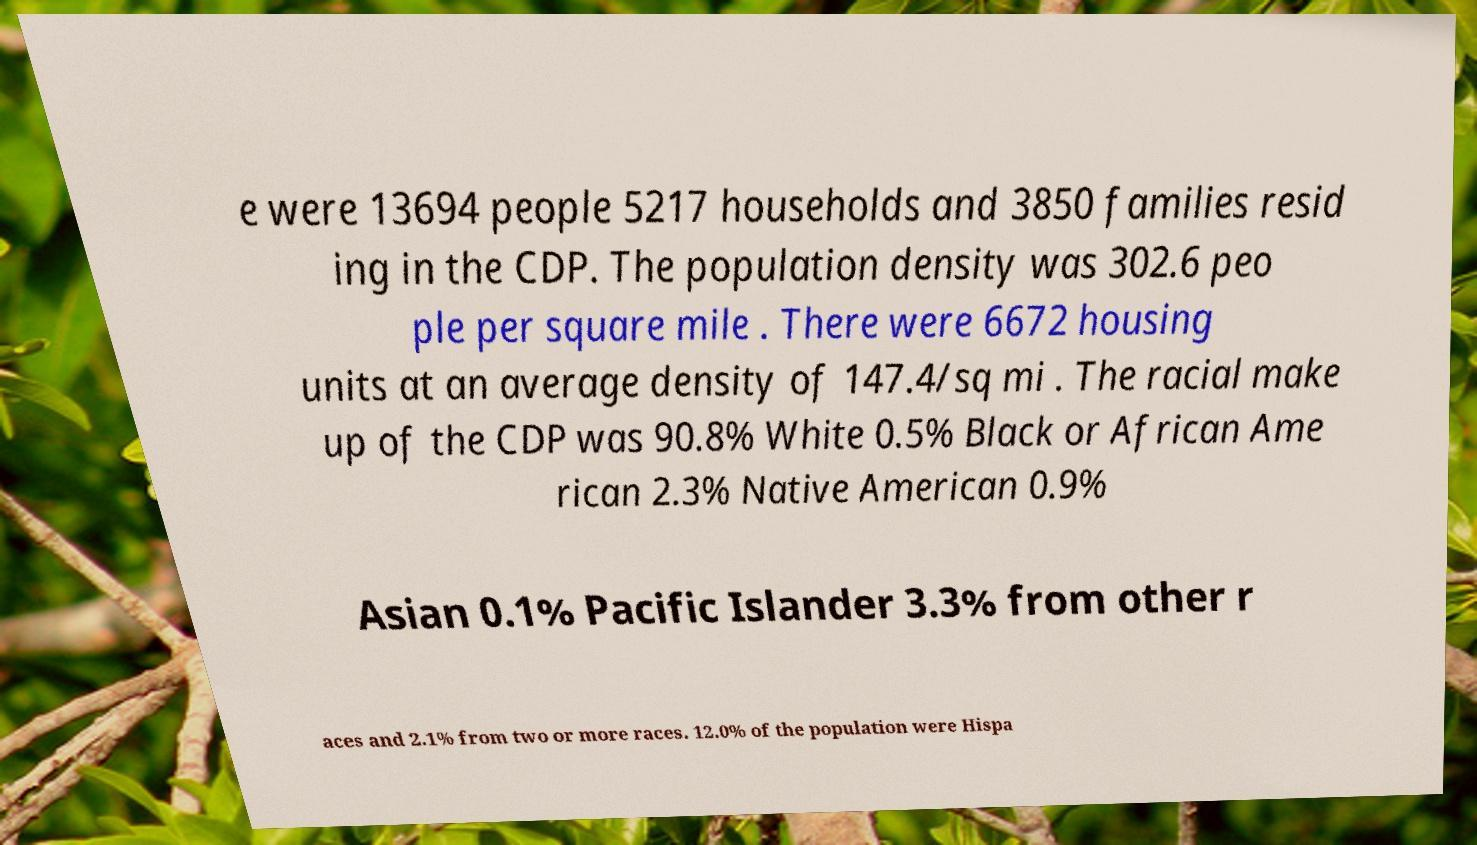What messages or text are displayed in this image? I need them in a readable, typed format. e were 13694 people 5217 households and 3850 families resid ing in the CDP. The population density was 302.6 peo ple per square mile . There were 6672 housing units at an average density of 147.4/sq mi . The racial make up of the CDP was 90.8% White 0.5% Black or African Ame rican 2.3% Native American 0.9% Asian 0.1% Pacific Islander 3.3% from other r aces and 2.1% from two or more races. 12.0% of the population were Hispa 